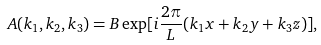Convert formula to latex. <formula><loc_0><loc_0><loc_500><loc_500>A ( k _ { 1 } , k _ { 2 } , k _ { 3 } ) = B \exp [ i \frac { 2 \pi } { L } ( k _ { 1 } x + k _ { 2 } y + k _ { 3 } z ) ] ,</formula> 